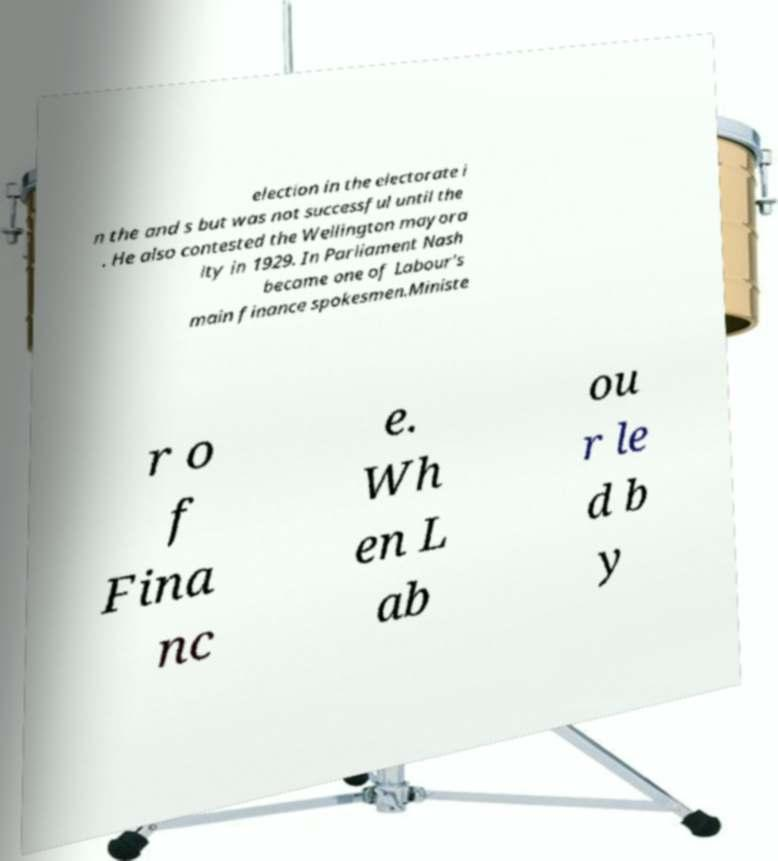What messages or text are displayed in this image? I need them in a readable, typed format. election in the electorate i n the and s but was not successful until the . He also contested the Wellington mayora lty in 1929. In Parliament Nash became one of Labour's main finance spokesmen.Ministe r o f Fina nc e. Wh en L ab ou r le d b y 